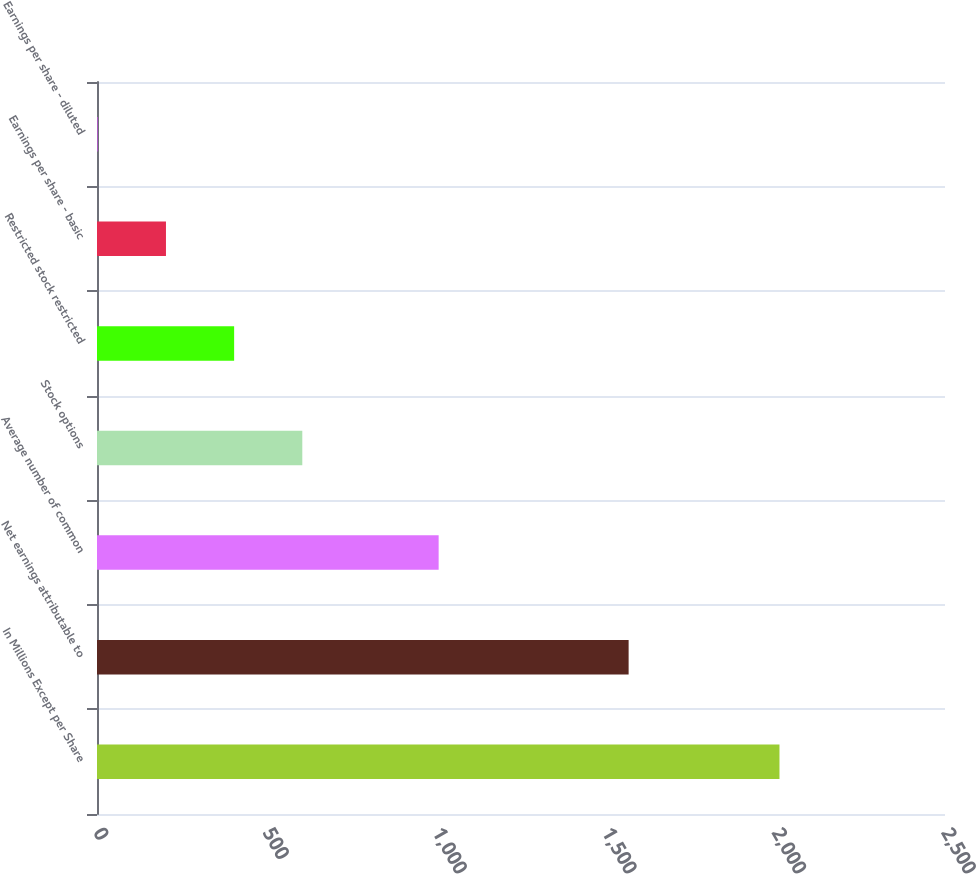Convert chart. <chart><loc_0><loc_0><loc_500><loc_500><bar_chart><fcel>In Millions Except per Share<fcel>Net earnings attributable to<fcel>Average number of common<fcel>Stock options<fcel>Restricted stock restricted<fcel>Earnings per share - basic<fcel>Earnings per share - diluted<nl><fcel>2012<fcel>1567.3<fcel>1007.2<fcel>605.26<fcel>404.29<fcel>203.32<fcel>2.35<nl></chart> 